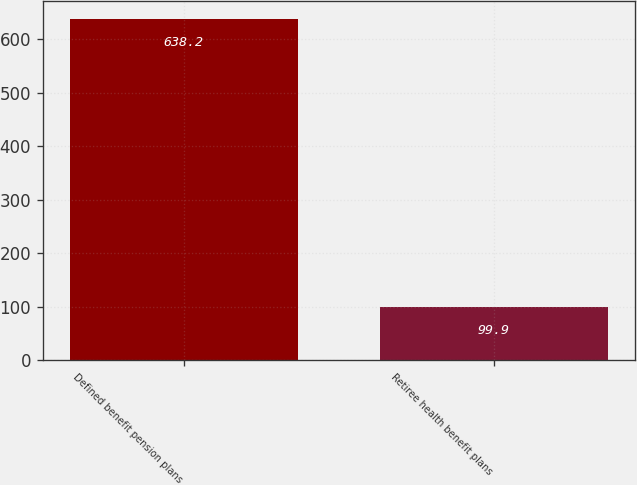<chart> <loc_0><loc_0><loc_500><loc_500><bar_chart><fcel>Defined benefit pension plans<fcel>Retiree health benefit plans<nl><fcel>638.2<fcel>99.9<nl></chart> 